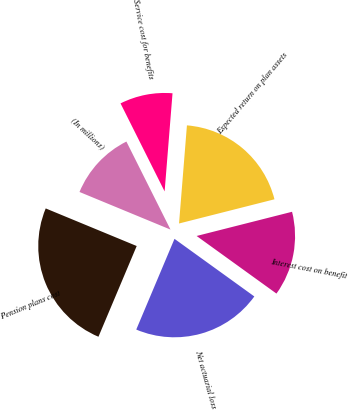Convert chart to OTSL. <chart><loc_0><loc_0><loc_500><loc_500><pie_chart><fcel>(In millions)<fcel>Service cost for benefits<fcel>Expected return on plan assets<fcel>Interest cost on benefit<fcel>Net actuarial loss<fcel>Pension plans cost<nl><fcel>11.37%<fcel>8.67%<fcel>19.77%<fcel>13.9%<fcel>21.4%<fcel>24.89%<nl></chart> 